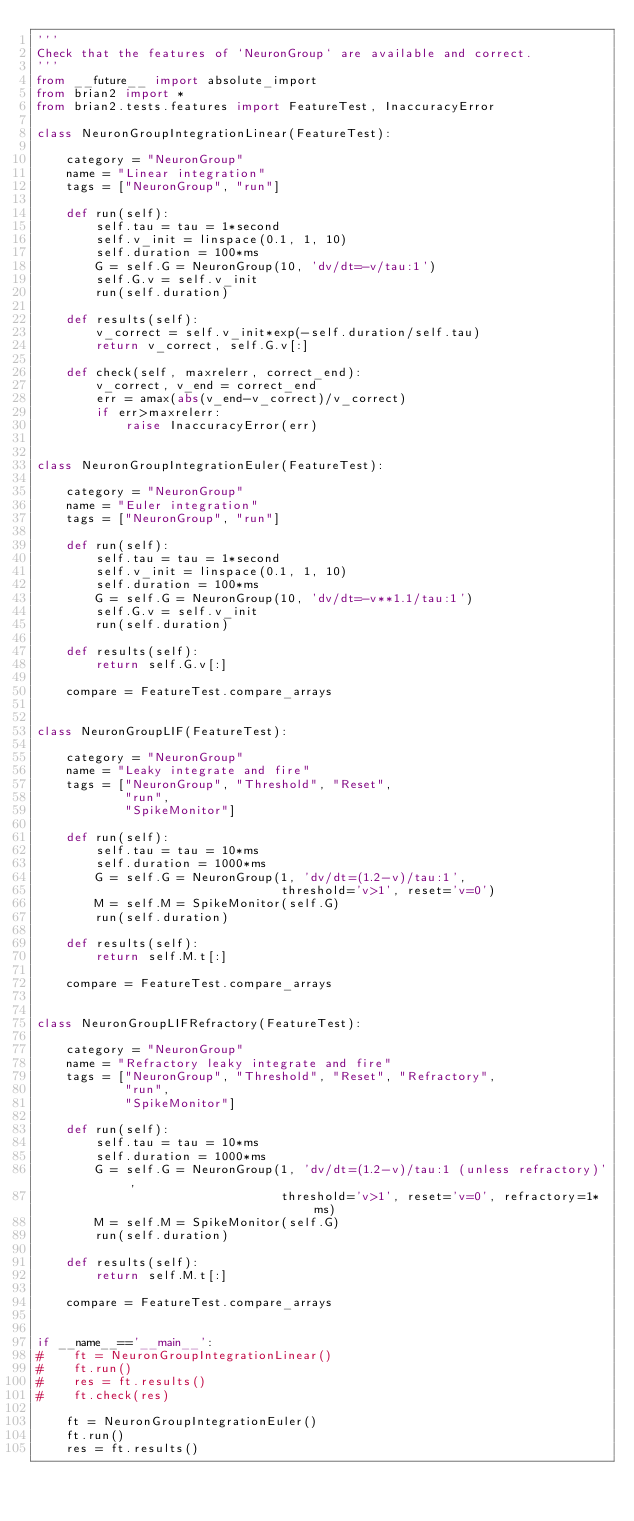<code> <loc_0><loc_0><loc_500><loc_500><_Python_>'''
Check that the features of `NeuronGroup` are available and correct.
'''
from __future__ import absolute_import
from brian2 import *
from brian2.tests.features import FeatureTest, InaccuracyError

class NeuronGroupIntegrationLinear(FeatureTest):
    
    category = "NeuronGroup"
    name = "Linear integration"
    tags = ["NeuronGroup", "run"]
    
    def run(self):
        self.tau = tau = 1*second
        self.v_init = linspace(0.1, 1, 10)
        self.duration = 100*ms
        G = self.G = NeuronGroup(10, 'dv/dt=-v/tau:1')
        self.G.v = self.v_init
        run(self.duration)
        
    def results(self):
        v_correct = self.v_init*exp(-self.duration/self.tau)
        return v_correct, self.G.v[:]
            
    def check(self, maxrelerr, correct_end):
        v_correct, v_end = correct_end
        err = amax(abs(v_end-v_correct)/v_correct)
        if err>maxrelerr:
            raise InaccuracyError(err)
            
    
class NeuronGroupIntegrationEuler(FeatureTest):
    
    category = "NeuronGroup"
    name = "Euler integration"
    tags = ["NeuronGroup", "run"]
    
    def run(self):
        self.tau = tau = 1*second
        self.v_init = linspace(0.1, 1, 10)
        self.duration = 100*ms
        G = self.G = NeuronGroup(10, 'dv/dt=-v**1.1/tau:1')
        self.G.v = self.v_init
        run(self.duration)
        
    def results(self):
        return self.G.v[:]
    
    compare = FeatureTest.compare_arrays


class NeuronGroupLIF(FeatureTest):
    
    category = "NeuronGroup"
    name = "Leaky integrate and fire"
    tags = ["NeuronGroup", "Threshold", "Reset",
            "run",
            "SpikeMonitor"]
    
    def run(self):
        self.tau = tau = 10*ms
        self.duration = 1000*ms
        G = self.G = NeuronGroup(1, 'dv/dt=(1.2-v)/tau:1',
                                 threshold='v>1', reset='v=0')
        M = self.M = SpikeMonitor(self.G)
        run(self.duration)
        
    def results(self):
        return self.M.t[:]
    
    compare = FeatureTest.compare_arrays


class NeuronGroupLIFRefractory(FeatureTest):
    
    category = "NeuronGroup"
    name = "Refractory leaky integrate and fire"
    tags = ["NeuronGroup", "Threshold", "Reset", "Refractory",
            "run",
            "SpikeMonitor"]
    
    def run(self):
        self.tau = tau = 10*ms
        self.duration = 1000*ms
        G = self.G = NeuronGroup(1, 'dv/dt=(1.2-v)/tau:1 (unless refractory)',
                                 threshold='v>1', reset='v=0', refractory=1*ms)
        M = self.M = SpikeMonitor(self.G)
        run(self.duration)
        
    def results(self):
        return self.M.t[:]
    
    compare = FeatureTest.compare_arrays

        
if __name__=='__main__':
#    ft = NeuronGroupIntegrationLinear()
#    ft.run()
#    res = ft.results()
#    ft.check(res)
    
    ft = NeuronGroupIntegrationEuler()
    ft.run()
    res = ft.results()
    </code> 